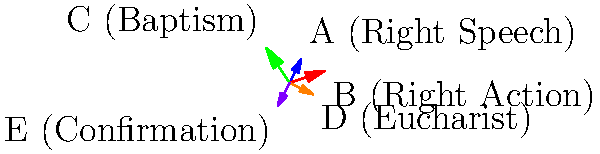In the given vector diagram, vectors A, B, and C represent three of the Five Precepts of Buddhism, while vectors D and E represent two of the Seven Sacraments of Catholicism. If we consider the sum of these vectors as a representation of the harmony between Buddhist and Catholic teachings, what is the magnitude of the resultant vector $\vec{R} = \vec{A} + \vec{B} + \vec{C} + \vec{D} + \vec{E}$? To find the magnitude of the resultant vector, we need to follow these steps:

1. Add the x-components and y-components of all vectors separately:

   $R_x = A_x + B_x + C_x + D_x + E_x$
   $R_y = A_y + B_y + C_y + D_y + E_y$

2. From the diagram, we can identify the components:
   $\vec{A} = (1, 2)$
   $\vec{B} = (3, 1)$
   $\vec{C} = (-2, 3)$
   $\vec{D} = (2, -1)$
   $\vec{E} = (-1, -2)$

3. Sum the x-components:
   $R_x = 1 + 3 + (-2) + 2 + (-1) = 3$

4. Sum the y-components:
   $R_y = 2 + 1 + 3 + (-1) + (-2) = 3$

5. The resultant vector $\vec{R}$ is therefore $(3, 3)$

6. To find the magnitude of $\vec{R}$, we use the Pythagorean theorem:

   $|\vec{R}| = \sqrt{R_x^2 + R_y^2} = \sqrt{3^2 + 3^2} = \sqrt{18}$

7. Simplify:
   $|\vec{R}| = 3\sqrt{2}$

Therefore, the magnitude of the resultant vector is $3\sqrt{2}$.
Answer: $3\sqrt{2}$ 